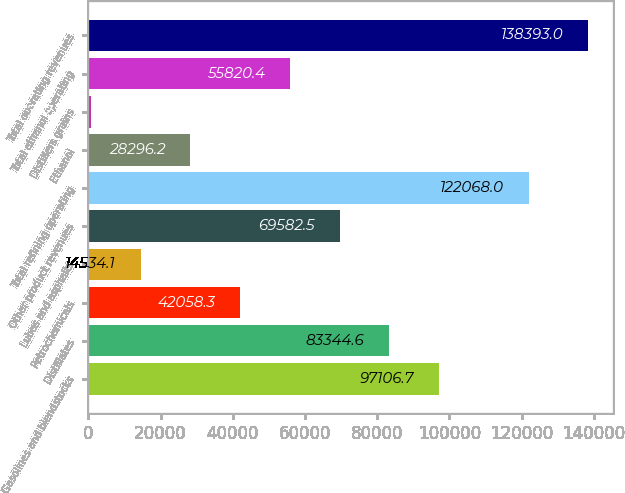<chart> <loc_0><loc_0><loc_500><loc_500><bar_chart><fcel>Gasolines and blendstocks<fcel>Distillates<fcel>Petrochemicals<fcel>Lubes and asphalts<fcel>Other product revenues<fcel>Total refining operating<fcel>Ethanol<fcel>Distillers grains<fcel>Total ethanol operating<fcel>Total operating revenues<nl><fcel>97106.7<fcel>83344.6<fcel>42058.3<fcel>14534.1<fcel>69582.5<fcel>122068<fcel>28296.2<fcel>772<fcel>55820.4<fcel>138393<nl></chart> 